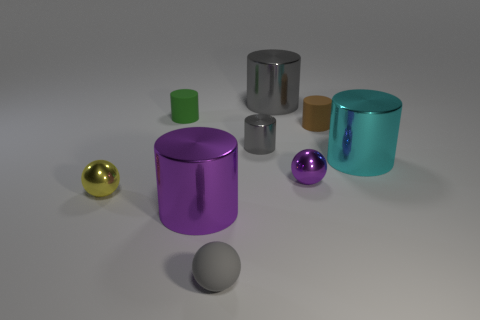What is the size of the rubber thing that is the same color as the small shiny cylinder?
Your response must be concise. Small. How many cylinders are green rubber objects or cyan metallic things?
Your answer should be very brief. 2. Is the shape of the rubber thing that is to the right of the gray rubber thing the same as  the big purple thing?
Provide a short and direct response. Yes. Is the number of gray cylinders that are in front of the tiny yellow sphere greater than the number of gray metallic spheres?
Your answer should be very brief. No. There is another rubber cylinder that is the same size as the green cylinder; what is its color?
Your answer should be very brief. Brown. What number of objects are large shiny things behind the tiny green rubber cylinder or tiny things?
Provide a short and direct response. 7. What shape is the tiny thing that is the same color as the tiny matte sphere?
Your answer should be very brief. Cylinder. What material is the purple object on the right side of the metallic cylinder that is in front of the yellow metal thing?
Provide a short and direct response. Metal. Is there a tiny cube made of the same material as the cyan object?
Give a very brief answer. No. There is a cylinder that is to the left of the purple metallic cylinder; are there any large cylinders that are behind it?
Provide a short and direct response. Yes. 